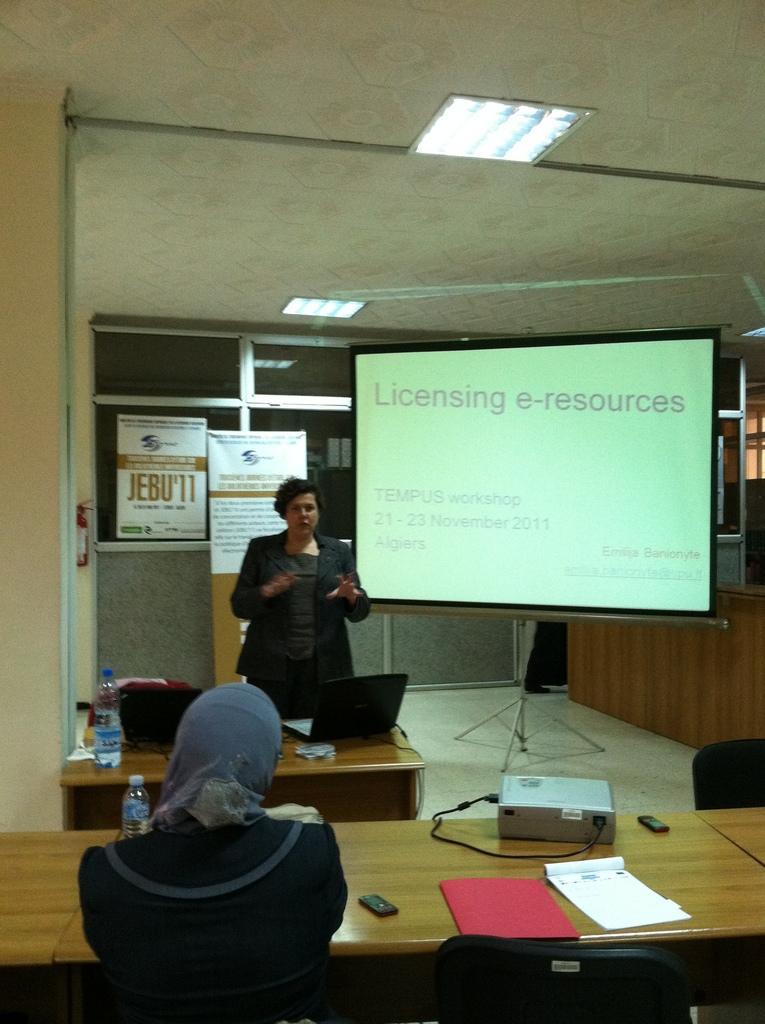In one or two sentences, can you explain what this image depicts? Here we can see a woman in the middle standing and explaining something and beside her we can see projector screen and in front of her we can see a table having a laptop, a bag and a bottle of water and at the bottom we can see a woman sitting on chair and having table in front of her with a projector, a book and a bottle of water present 